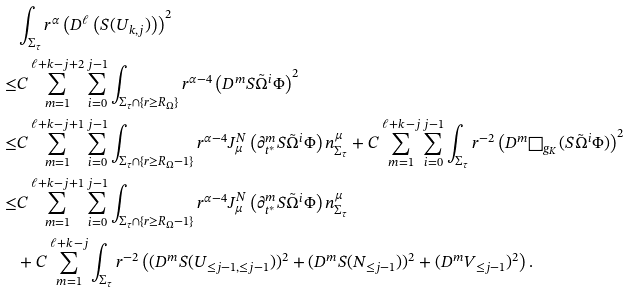Convert formula to latex. <formula><loc_0><loc_0><loc_500><loc_500>& \int _ { \Sigma _ { \tau } } r ^ { \alpha } \left ( D ^ { \ell } \left ( S ( U _ { k , j } ) \right ) \right ) ^ { 2 } \\ \leq & C \sum _ { m = 1 } ^ { \ell + k - j + 2 } \sum _ { i = 0 } ^ { j - 1 } \int _ { \Sigma _ { \tau } \cap \{ r \geq R _ { \Omega } \} } r ^ { \alpha - 4 } \left ( D ^ { m } S \tilde { \Omega } ^ { i } \Phi \right ) ^ { 2 } \\ \leq & C \sum _ { m = 1 } ^ { \ell + k - j + 1 } \sum _ { i = 0 } ^ { j - 1 } \int _ { \Sigma _ { \tau } \cap \{ r \geq R _ { \Omega } - 1 \} } r ^ { \alpha - 4 } J ^ { N } _ { \mu } \left ( \partial _ { t ^ { * } } ^ { m } S \tilde { \Omega } ^ { i } \Phi \right ) n ^ { \mu } _ { \Sigma _ { \tau } } + C \sum _ { m = 1 } ^ { \ell + k - j } \sum _ { i = 0 } ^ { j - 1 } \int _ { \Sigma _ { \tau } } r ^ { - 2 } \left ( D ^ { m } \Box _ { g _ { K } } ( S \tilde { \Omega } ^ { i } \Phi ) \right ) ^ { 2 } \\ \leq & C \sum _ { m = 1 } ^ { \ell + k - j + 1 } \sum _ { i = 0 } ^ { j - 1 } \int _ { \Sigma _ { \tau } \cap \{ r \geq R _ { \Omega } - 1 \} } r ^ { \alpha - 4 } J ^ { N } _ { \mu } \left ( \partial _ { t ^ { * } } ^ { m } S \tilde { \Omega } ^ { i } \Phi \right ) n ^ { \mu } _ { \Sigma _ { \tau } } \\ & + C \sum _ { m = 1 } ^ { \ell + k - j } \int _ { \Sigma _ { \tau } } r ^ { - 2 } \left ( ( D ^ { m } S ( U _ { \leq j - 1 , \leq j - 1 } ) ) ^ { 2 } + ( D ^ { m } S ( N _ { \leq j - 1 } ) ) ^ { 2 } + ( D ^ { m } V _ { \leq j - 1 } ) ^ { 2 } \right ) .</formula> 